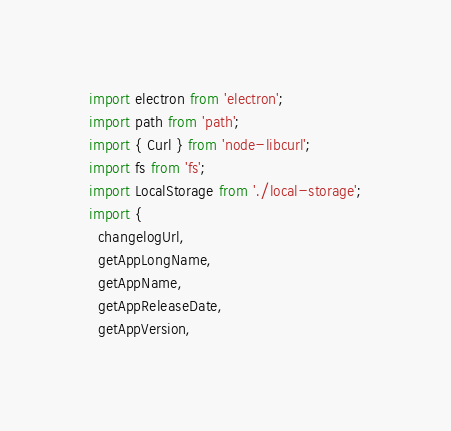Convert code to text. <code><loc_0><loc_0><loc_500><loc_500><_JavaScript_>import electron from 'electron';
import path from 'path';
import { Curl } from 'node-libcurl';
import fs from 'fs';
import LocalStorage from './local-storage';
import {
  changelogUrl,
  getAppLongName,
  getAppName,
  getAppReleaseDate,
  getAppVersion,</code> 